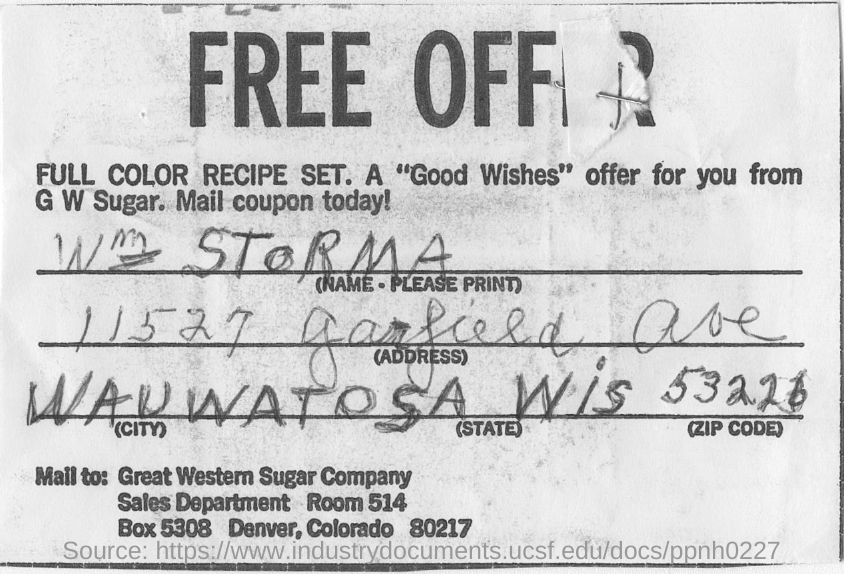Which city is W STORMA in?
Give a very brief answer. WAUWATOSA. What is the zip code?
Offer a terse response. 53226. 